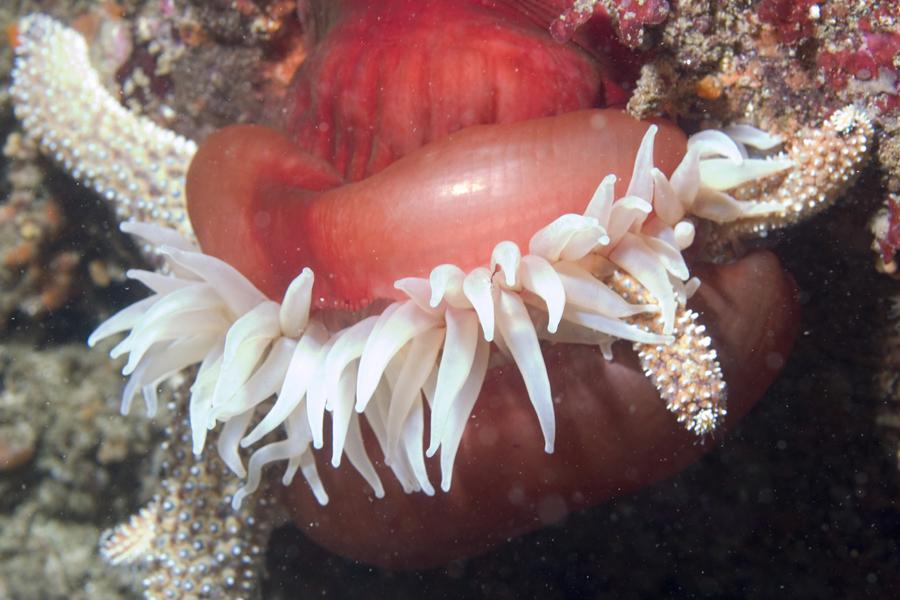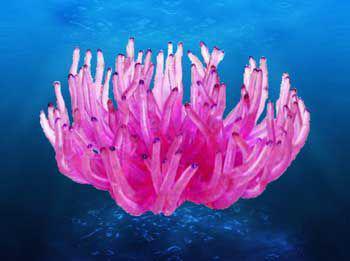The first image is the image on the left, the second image is the image on the right. Given the left and right images, does the statement "An image features an anemone with pale tendrils and a rosy-orange body." hold true? Answer yes or no. Yes. 